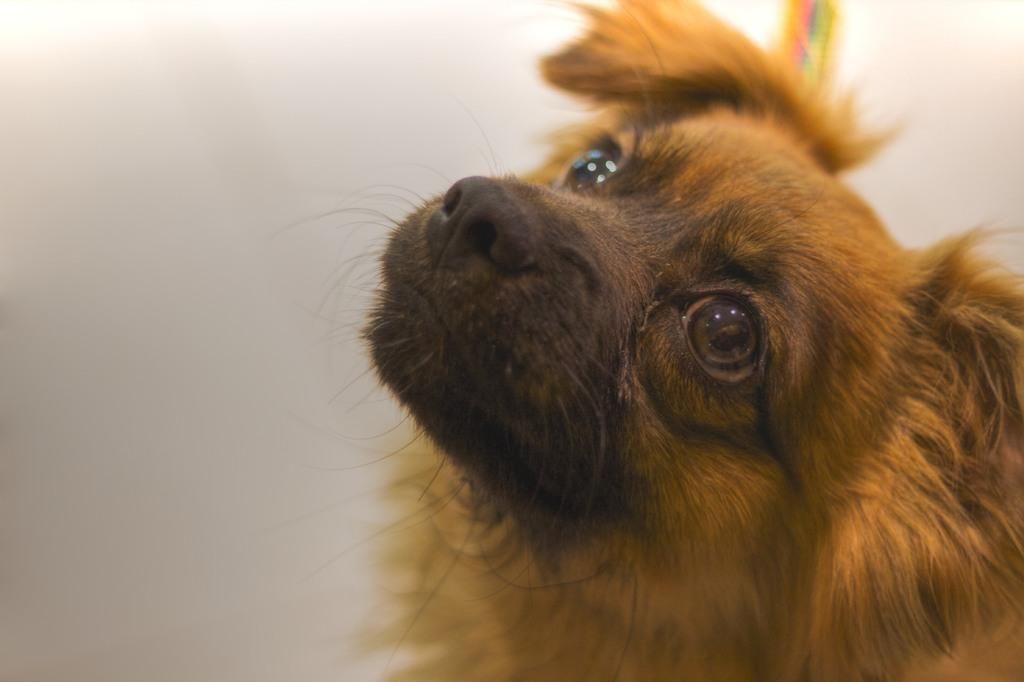What type of animal is present in the image? There is a dog in the image. What flavor of cake is being served by the bear in the image? There is no cake or bear present in the image; it only features a dog. 